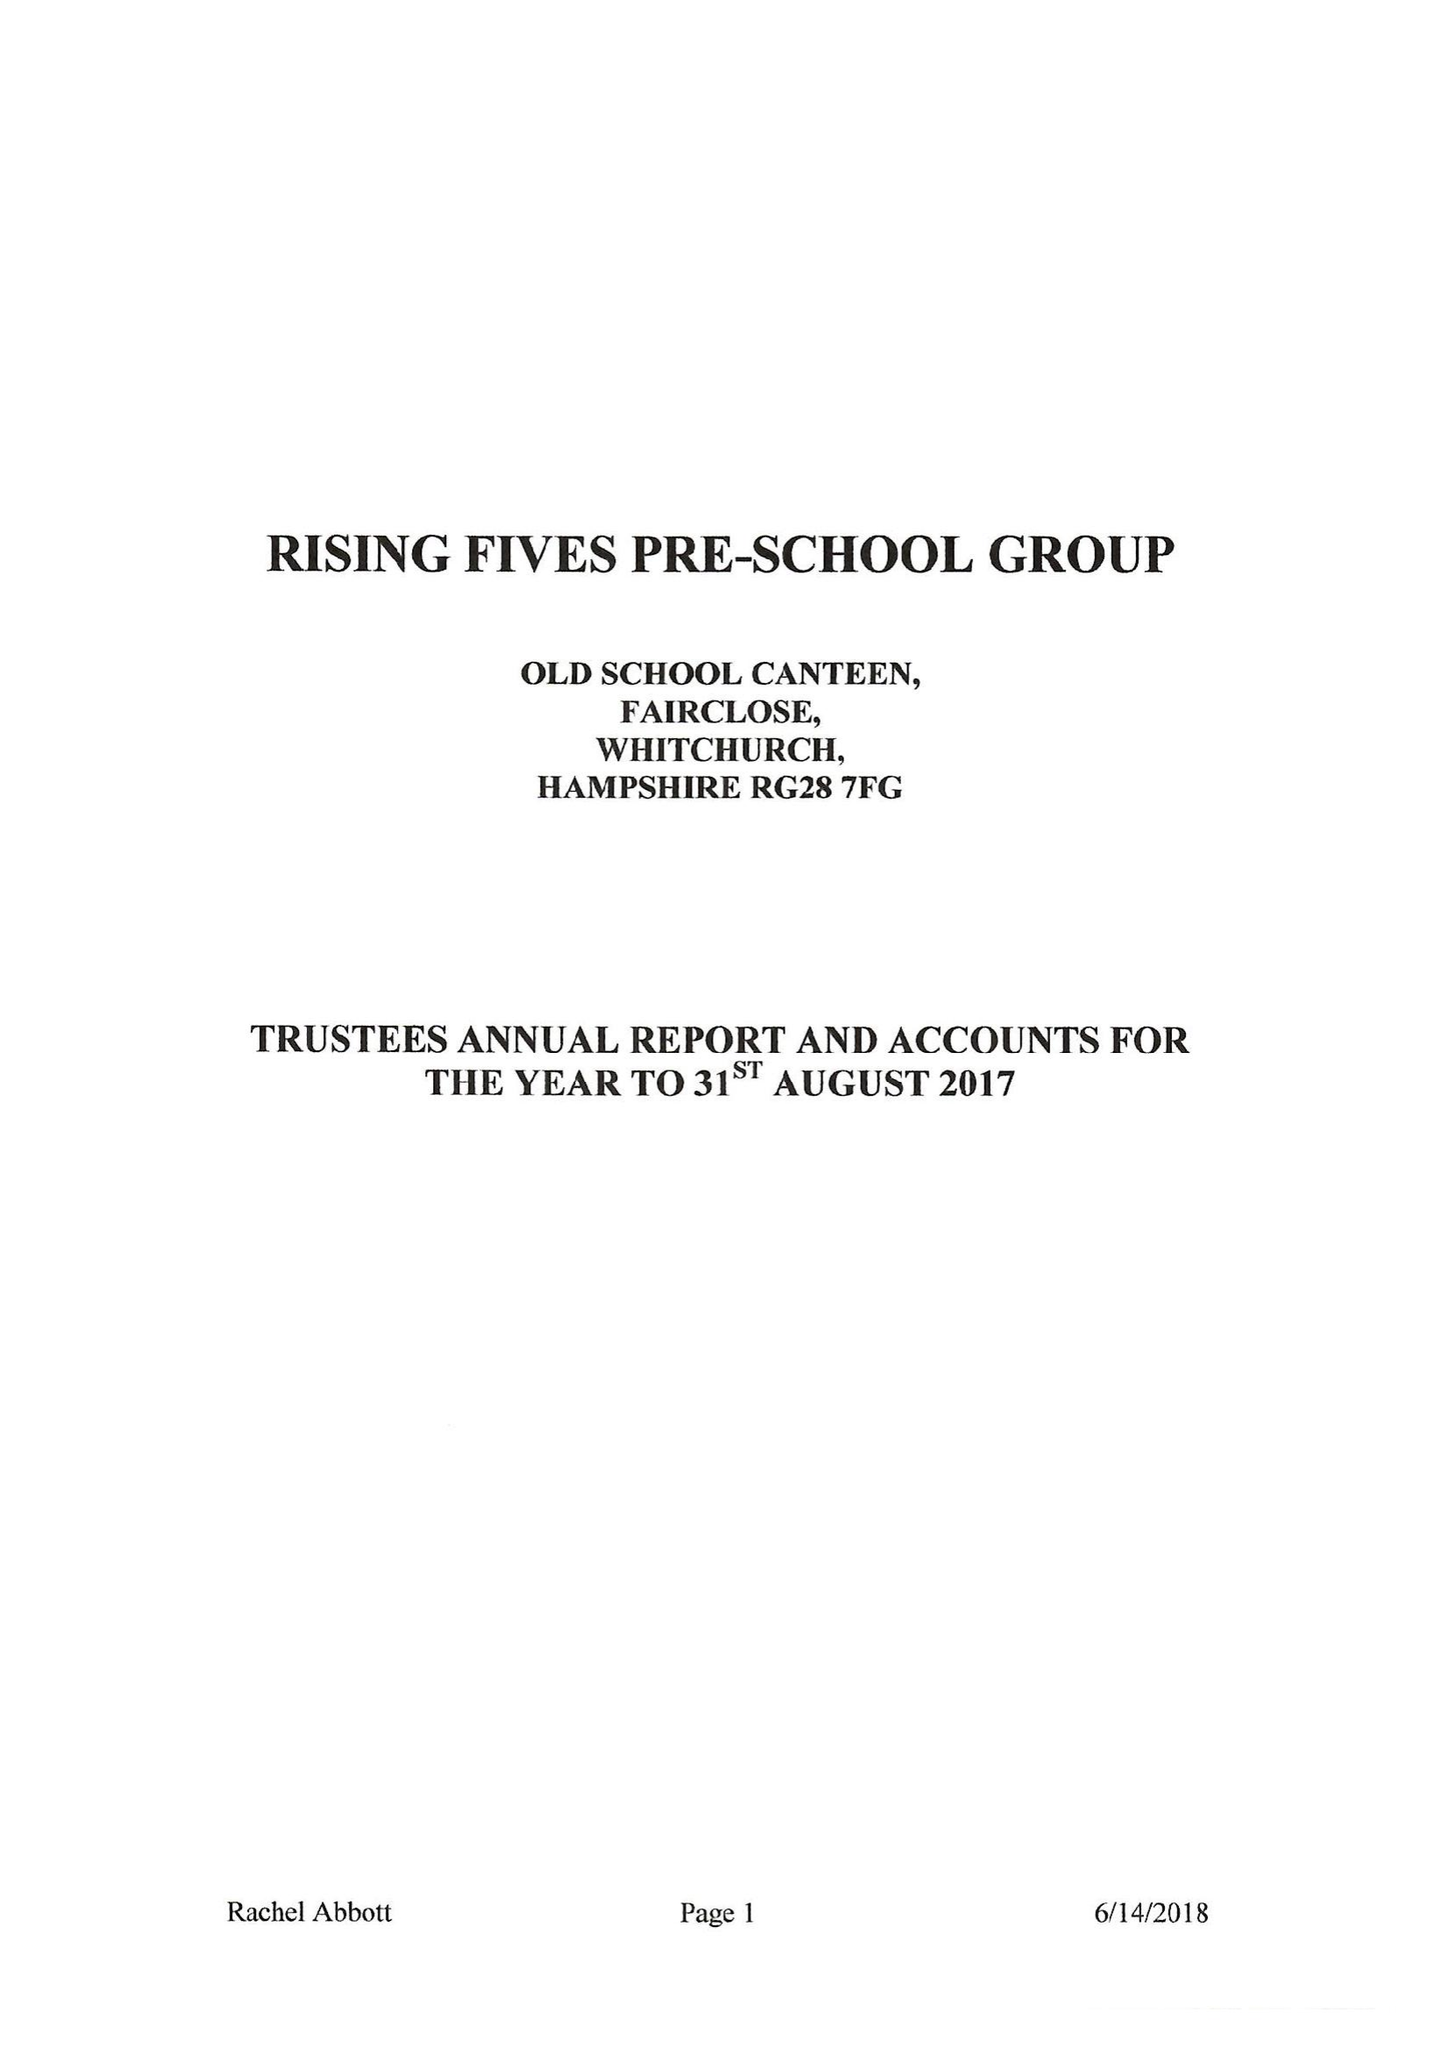What is the value for the charity_number?
Answer the question using a single word or phrase. 270065 